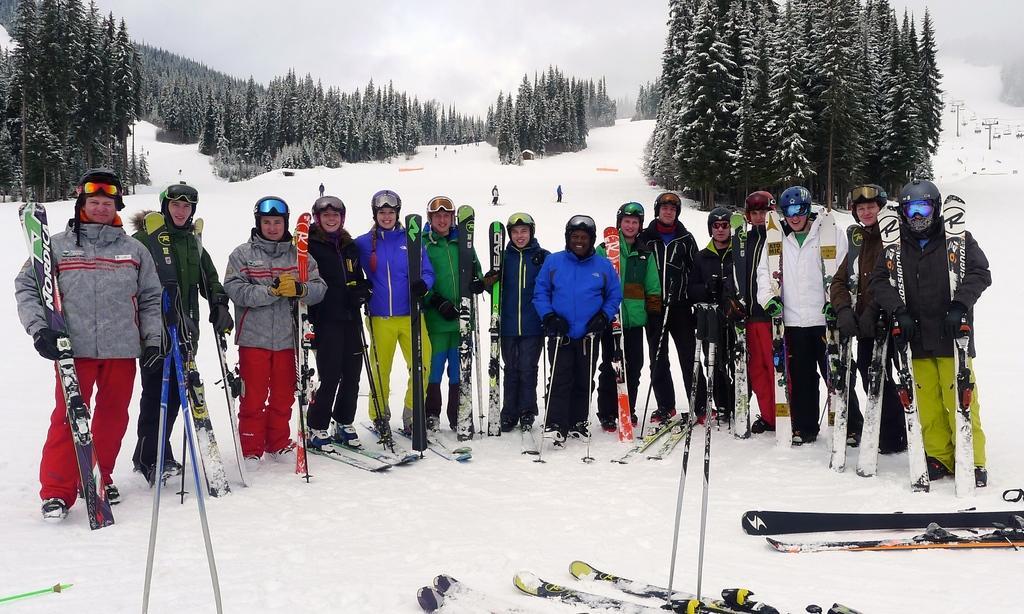Please provide a concise description of this image. In this picture we can see a group of people wore goggles, gloves, shoes and standing on snow and smiling and beside them we can see skis and in the background we can see poles, trees, sky with clouds. 